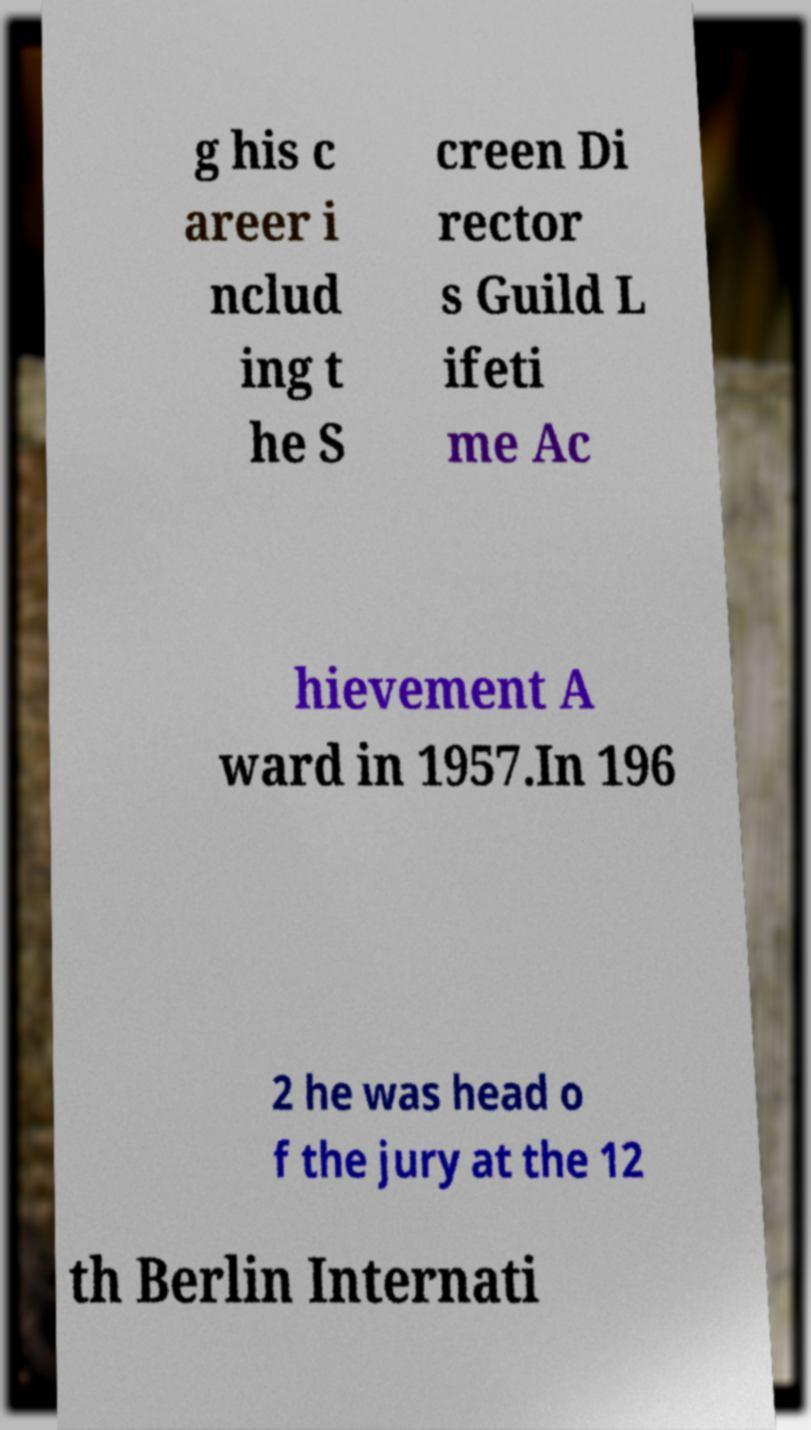Can you read and provide the text displayed in the image?This photo seems to have some interesting text. Can you extract and type it out for me? g his c areer i nclud ing t he S creen Di rector s Guild L ifeti me Ac hievement A ward in 1957.In 196 2 he was head o f the jury at the 12 th Berlin Internati 